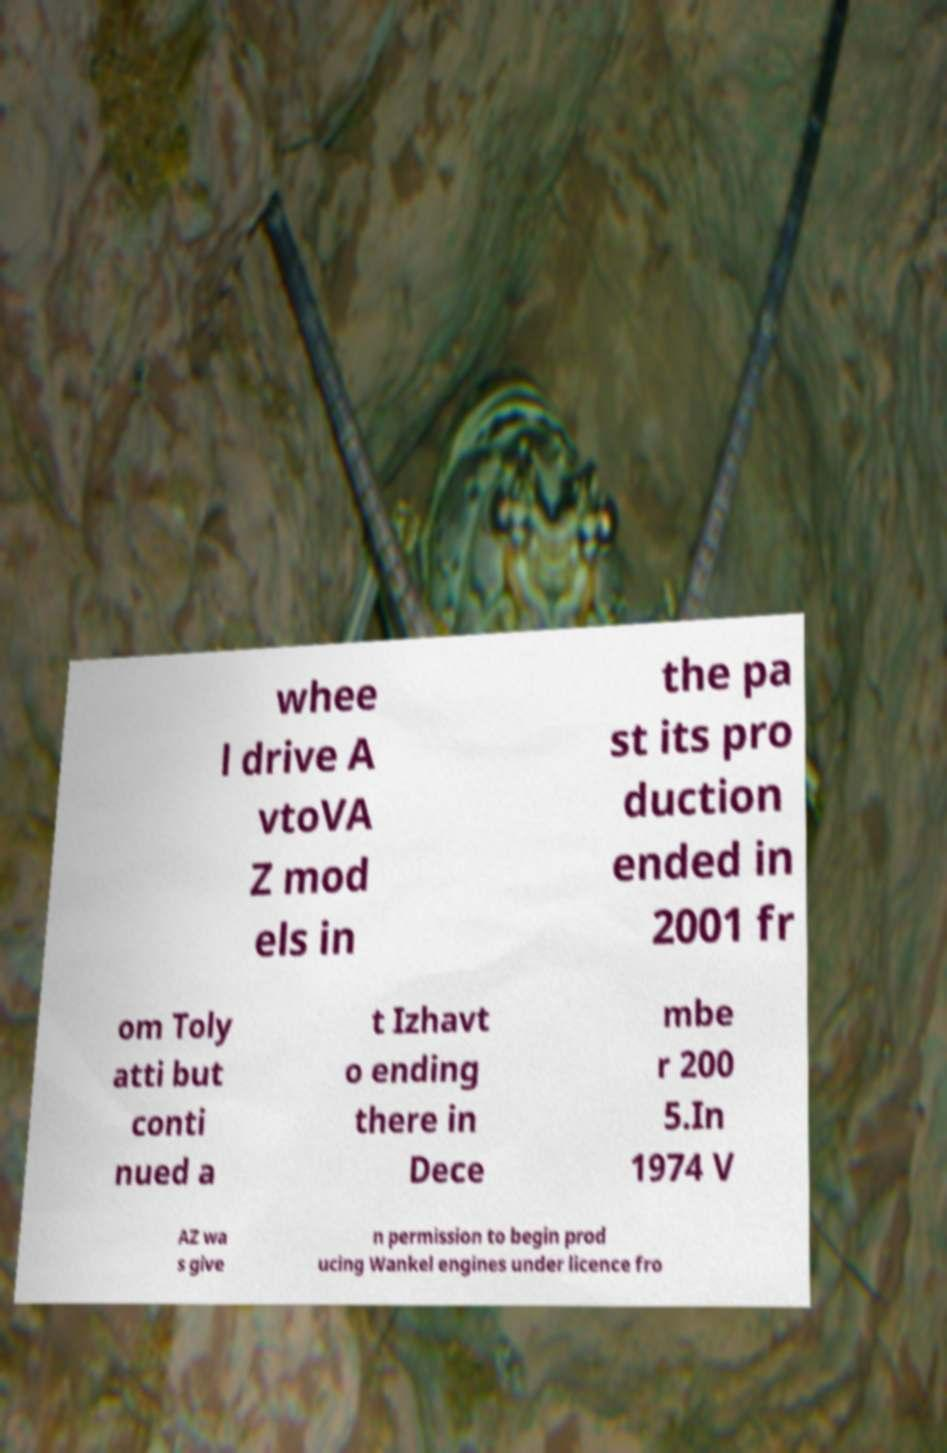Please read and relay the text visible in this image. What does it say? whee l drive A vtoVA Z mod els in the pa st its pro duction ended in 2001 fr om Toly atti but conti nued a t Izhavt o ending there in Dece mbe r 200 5.In 1974 V AZ wa s give n permission to begin prod ucing Wankel engines under licence fro 